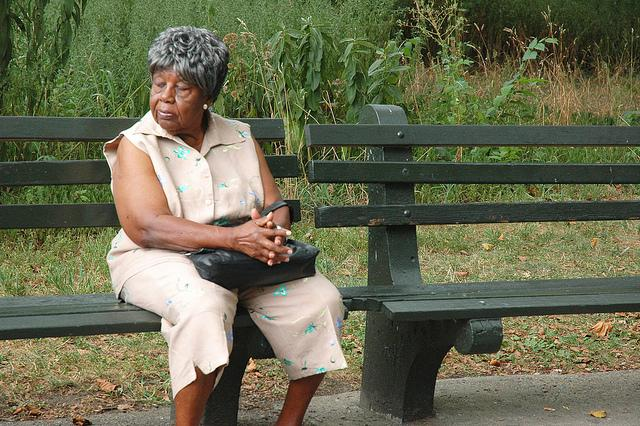What activity is the old lady engaging in? Please explain your reasoning. resting. The woman is hanging out on the bench. 